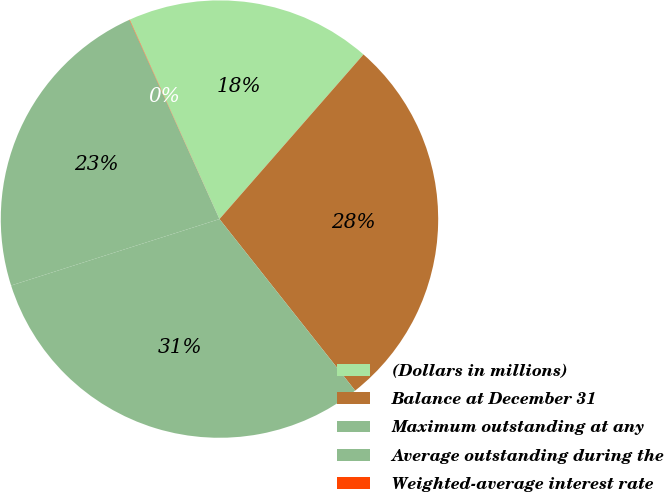Convert chart. <chart><loc_0><loc_0><loc_500><loc_500><pie_chart><fcel>(Dollars in millions)<fcel>Balance at December 31<fcel>Maximum outstanding at any<fcel>Average outstanding during the<fcel>Weighted-average interest rate<nl><fcel>18.17%<fcel>27.91%<fcel>30.74%<fcel>23.15%<fcel>0.03%<nl></chart> 